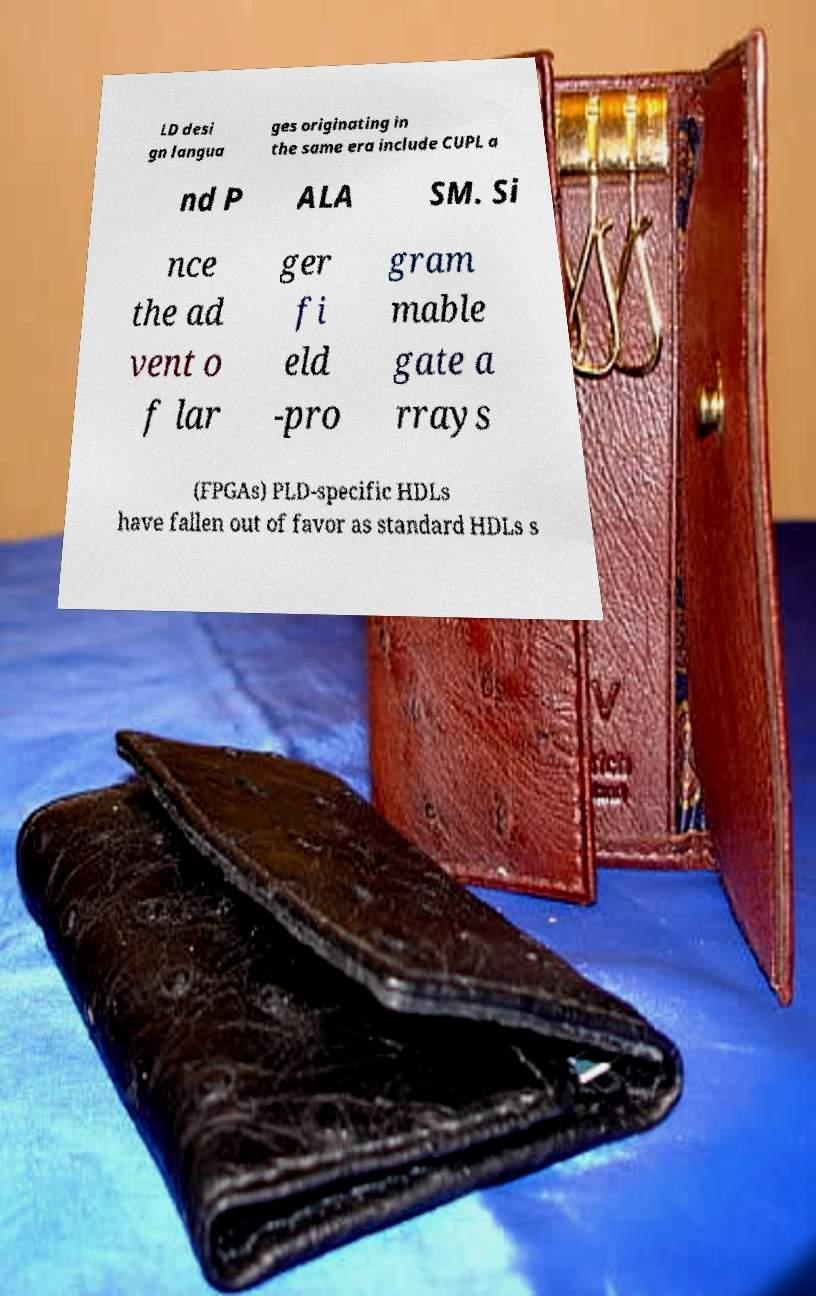Please read and relay the text visible in this image. What does it say? LD desi gn langua ges originating in the same era include CUPL a nd P ALA SM. Si nce the ad vent o f lar ger fi eld -pro gram mable gate a rrays (FPGAs) PLD-specific HDLs have fallen out of favor as standard HDLs s 